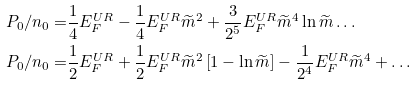Convert formula to latex. <formula><loc_0><loc_0><loc_500><loc_500>P _ { 0 } / n _ { 0 } = & \frac { 1 } { 4 } E _ { F } ^ { U R } - \frac { 1 } { 4 } E _ { F } ^ { U R } \widetilde { m } ^ { 2 } + \frac { 3 } { 2 ^ { 5 } } E _ { F } ^ { U R } \widetilde { m } ^ { 4 } \ln \widetilde { m } \dots \\ P _ { 0 } / n _ { 0 } = & \frac { 1 } { 2 } E _ { F } ^ { U R } + \frac { 1 } { 2 } E _ { F } ^ { U R } \widetilde { m } ^ { 2 } \left [ 1 - \ln \widetilde { m } \right ] - \frac { 1 } { 2 ^ { 4 } } E _ { F } ^ { U R } \widetilde { m } ^ { 4 } + \dots</formula> 